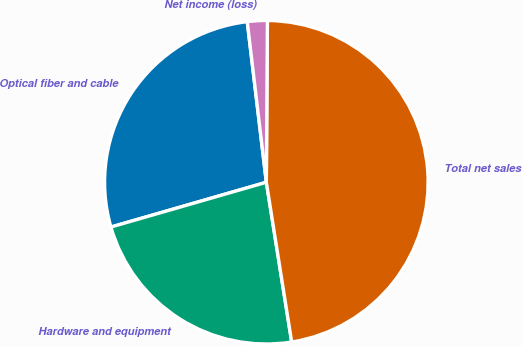<chart> <loc_0><loc_0><loc_500><loc_500><pie_chart><fcel>Optical fiber and cable<fcel>Hardware and equipment<fcel>Total net sales<fcel>Net income (loss)<nl><fcel>27.58%<fcel>23.04%<fcel>47.39%<fcel>1.99%<nl></chart> 